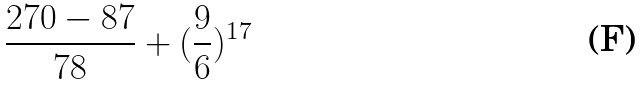Convert formula to latex. <formula><loc_0><loc_0><loc_500><loc_500>\frac { 2 7 0 - 8 7 } { 7 8 } + ( \frac { 9 } { 6 } ) ^ { 1 7 }</formula> 